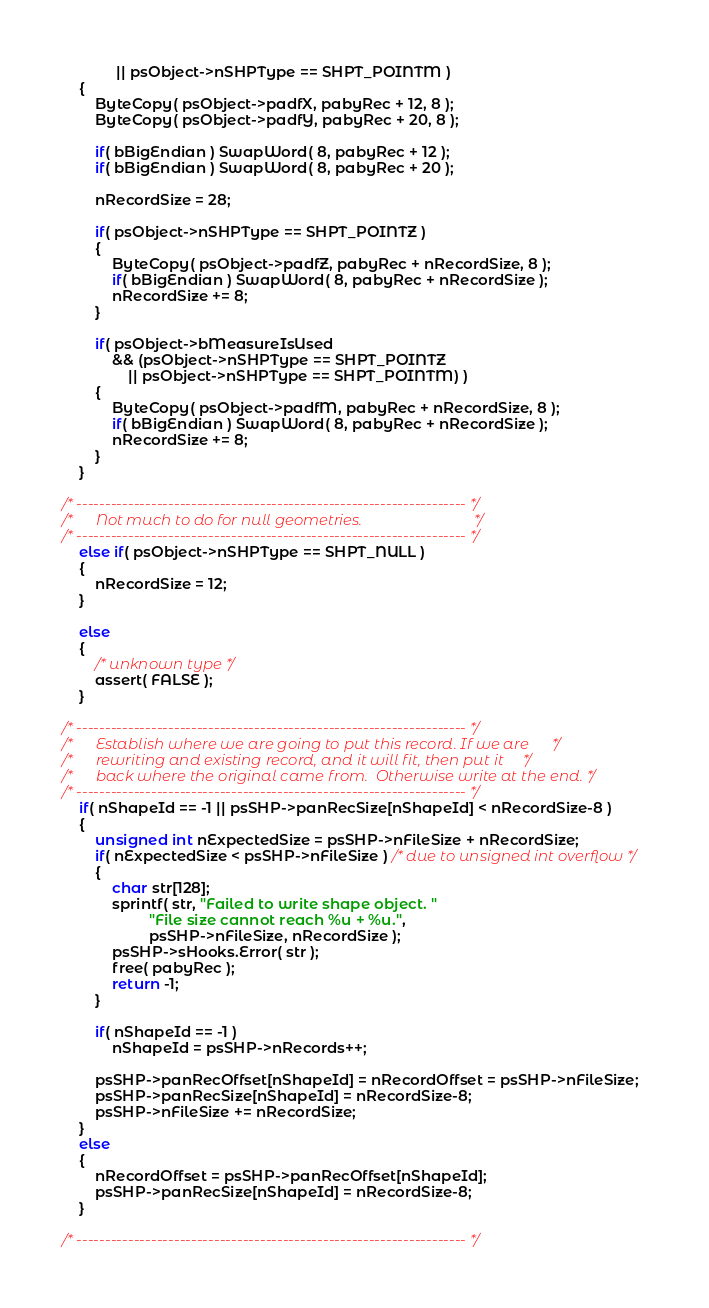<code> <loc_0><loc_0><loc_500><loc_500><_C_>             || psObject->nSHPType == SHPT_POINTM )
    {
        ByteCopy( psObject->padfX, pabyRec + 12, 8 );
        ByteCopy( psObject->padfY, pabyRec + 20, 8 );

        if( bBigEndian ) SwapWord( 8, pabyRec + 12 );
        if( bBigEndian ) SwapWord( 8, pabyRec + 20 );

        nRecordSize = 28;
        
        if( psObject->nSHPType == SHPT_POINTZ )
        {
            ByteCopy( psObject->padfZ, pabyRec + nRecordSize, 8 );
            if( bBigEndian ) SwapWord( 8, pabyRec + nRecordSize );
            nRecordSize += 8;
        }
        
        if( psObject->bMeasureIsUsed
            && (psObject->nSHPType == SHPT_POINTZ
                || psObject->nSHPType == SHPT_POINTM) )
        {
            ByteCopy( psObject->padfM, pabyRec + nRecordSize, 8 );
            if( bBigEndian ) SwapWord( 8, pabyRec + nRecordSize );
            nRecordSize += 8;
        }
    }

/* -------------------------------------------------------------------- */
/*      Not much to do for null geometries.                             */
/* -------------------------------------------------------------------- */
    else if( psObject->nSHPType == SHPT_NULL )
    {
        nRecordSize = 12;
    }

    else
    {
        /* unknown type */
        assert( FALSE );
    }

/* -------------------------------------------------------------------- */
/*      Establish where we are going to put this record. If we are      */
/*      rewriting and existing record, and it will fit, then put it     */
/*      back where the original came from.  Otherwise write at the end. */
/* -------------------------------------------------------------------- */
    if( nShapeId == -1 || psSHP->panRecSize[nShapeId] < nRecordSize-8 )
    {
        unsigned int nExpectedSize = psSHP->nFileSize + nRecordSize;
        if( nExpectedSize < psSHP->nFileSize ) /* due to unsigned int overflow */
        {
            char str[128];
            sprintf( str, "Failed to write shape object. "
                     "File size cannot reach %u + %u.",
                     psSHP->nFileSize, nRecordSize );
            psSHP->sHooks.Error( str );
            free( pabyRec );
            return -1;
        }

        if( nShapeId == -1 )
            nShapeId = psSHP->nRecords++;

        psSHP->panRecOffset[nShapeId] = nRecordOffset = psSHP->nFileSize;
        psSHP->panRecSize[nShapeId] = nRecordSize-8;
        psSHP->nFileSize += nRecordSize;
    }
    else
    {
        nRecordOffset = psSHP->panRecOffset[nShapeId];
        psSHP->panRecSize[nShapeId] = nRecordSize-8;
    }
    
/* -------------------------------------------------------------------- */</code> 